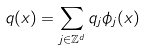<formula> <loc_0><loc_0><loc_500><loc_500>q ( x ) = \sum _ { j \in \mathbb { Z } ^ { d } } q _ { j } \phi _ { j } ( x )</formula> 